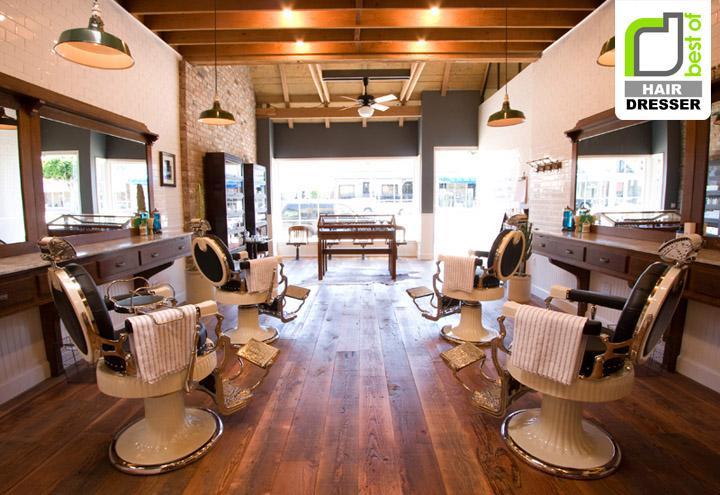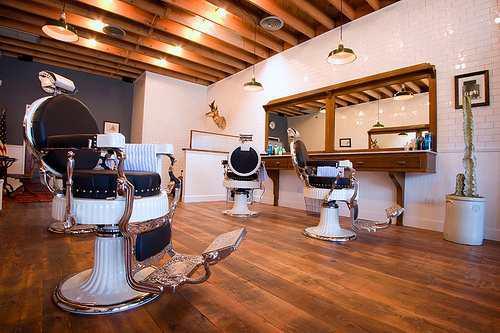The first image is the image on the left, the second image is the image on the right. For the images shown, is this caption "The chairs on the right side are white and black." true? Answer yes or no. Yes. 